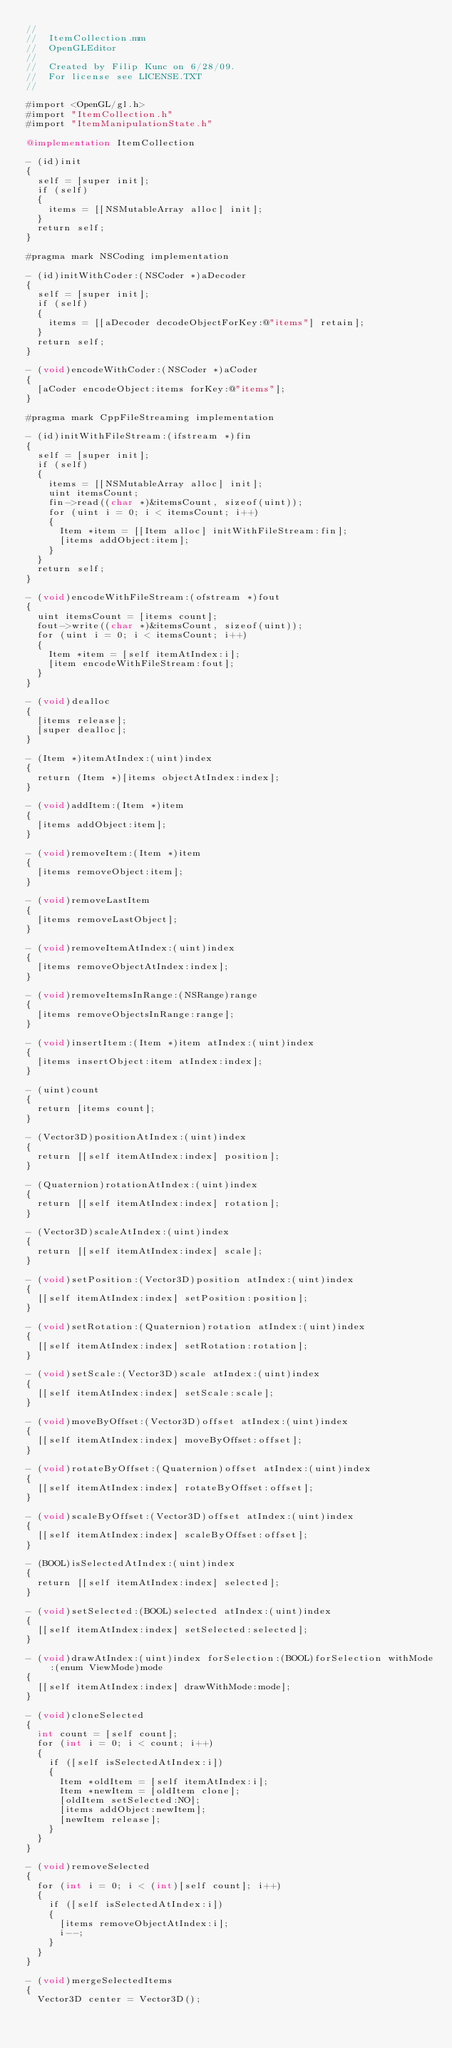<code> <loc_0><loc_0><loc_500><loc_500><_ObjectiveC_>//
//  ItemCollection.mm
//  OpenGLEditor
//
//  Created by Filip Kunc on 6/28/09.
//  For license see LICENSE.TXT
//

#import <OpenGL/gl.h>
#import "ItemCollection.h"
#import "ItemManipulationState.h"

@implementation ItemCollection

- (id)init
{
	self = [super init];
	if (self)
	{
		items = [[NSMutableArray alloc] init];
	}
	return self;
}

#pragma mark NSCoding implementation

- (id)initWithCoder:(NSCoder *)aDecoder
{
	self = [super init];
	if (self)
	{
		items = [[aDecoder decodeObjectForKey:@"items"] retain];
	}
	return self;
}

- (void)encodeWithCoder:(NSCoder *)aCoder
{
	[aCoder encodeObject:items forKey:@"items"];
}

#pragma mark CppFileStreaming implementation

- (id)initWithFileStream:(ifstream *)fin
{
	self = [super init];
	if (self)
	{
		items = [[NSMutableArray alloc] init];
		uint itemsCount;
		fin->read((char *)&itemsCount, sizeof(uint));
		for (uint i = 0; i < itemsCount; i++)
		{
			Item *item = [[Item alloc] initWithFileStream:fin];
			[items addObject:item];
		}
	}
	return self;
}

- (void)encodeWithFileStream:(ofstream *)fout
{
	uint itemsCount = [items count];
	fout->write((char *)&itemsCount, sizeof(uint));
	for (uint i = 0; i < itemsCount; i++)
	{		
		Item *item = [self itemAtIndex:i];
		[item encodeWithFileStream:fout];
	}
}

- (void)dealloc
{
	[items release];
	[super dealloc];
}

- (Item *)itemAtIndex:(uint)index
{
	return (Item *)[items objectAtIndex:index];
}

- (void)addItem:(Item *)item
{
	[items addObject:item];
}

- (void)removeItem:(Item *)item
{
	[items removeObject:item];
}

- (void)removeLastItem
{
	[items removeLastObject];
}

- (void)removeItemAtIndex:(uint)index
{
	[items removeObjectAtIndex:index];
}

- (void)removeItemsInRange:(NSRange)range
{
	[items removeObjectsInRange:range];
}

- (void)insertItem:(Item *)item atIndex:(uint)index
{
	[items insertObject:item atIndex:index];
}

- (uint)count
{
	return [items count];
}

- (Vector3D)positionAtIndex:(uint)index
{
	return [[self itemAtIndex:index] position];
}

- (Quaternion)rotationAtIndex:(uint)index
{
	return [[self itemAtIndex:index] rotation];
}

- (Vector3D)scaleAtIndex:(uint)index
{
	return [[self itemAtIndex:index] scale];
}

- (void)setPosition:(Vector3D)position atIndex:(uint)index
{
	[[self itemAtIndex:index] setPosition:position];
}

- (void)setRotation:(Quaternion)rotation atIndex:(uint)index
{
	[[self itemAtIndex:index] setRotation:rotation];
}

- (void)setScale:(Vector3D)scale atIndex:(uint)index
{
	[[self itemAtIndex:index] setScale:scale];
}

- (void)moveByOffset:(Vector3D)offset atIndex:(uint)index
{
	[[self itemAtIndex:index] moveByOffset:offset];
}

- (void)rotateByOffset:(Quaternion)offset atIndex:(uint)index
{
	[[self itemAtIndex:index] rotateByOffset:offset];
}

- (void)scaleByOffset:(Vector3D)offset atIndex:(uint)index
{
	[[self itemAtIndex:index] scaleByOffset:offset];
}

- (BOOL)isSelectedAtIndex:(uint)index
{
	return [[self itemAtIndex:index] selected];
}

- (void)setSelected:(BOOL)selected atIndex:(uint)index
{
	[[self itemAtIndex:index] setSelected:selected];
}

- (void)drawAtIndex:(uint)index forSelection:(BOOL)forSelection withMode:(enum ViewMode)mode
{
	[[self itemAtIndex:index] drawWithMode:mode];
}

- (void)cloneSelected
{
	int count = [self count];
	for (int i = 0; i < count; i++)
	{
		if ([self isSelectedAtIndex:i])
		{
			Item *oldItem = [self itemAtIndex:i];
			Item *newItem = [oldItem clone];
			[oldItem setSelected:NO];
			[items addObject:newItem];
			[newItem release];
		}
	}
}

- (void)removeSelected
{
	for (int i = 0; i < (int)[self count]; i++)
	{
		if ([self isSelectedAtIndex:i])
		{
			[items removeObjectAtIndex:i];
			i--;
		}
	}
}

- (void)mergeSelectedItems
{
	Vector3D center = Vector3D();</code> 